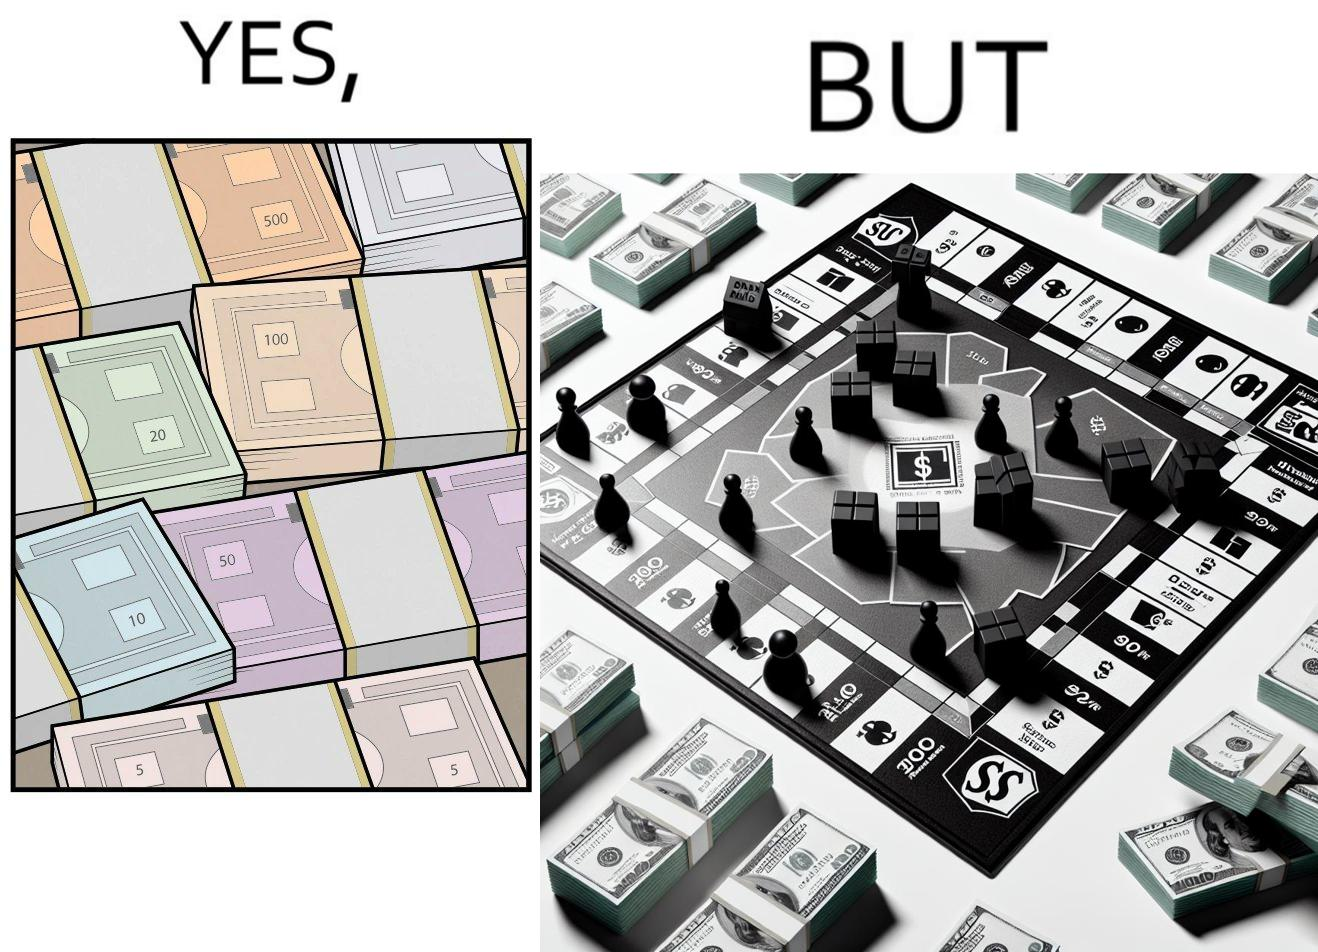What do you see in each half of this image? In the left part of the image: many different color currency notes' bundles In the right part of the image: a board of game monopoly with many different color currency notes' bundles 